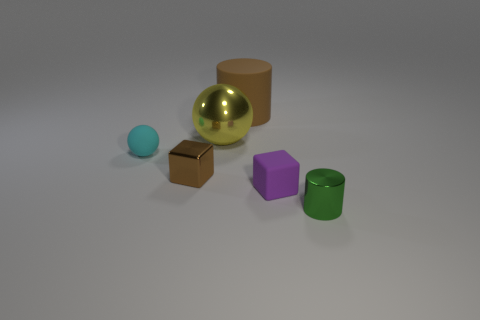The shiny object in front of the brown object that is in front of the rubber object behind the large yellow shiny thing is what shape?
Your answer should be compact. Cylinder. There is a tiny cylinder; what number of cylinders are to the left of it?
Keep it short and to the point. 1. Is the material of the cube to the left of the metallic sphere the same as the cyan ball?
Provide a short and direct response. No. How many other things are there of the same shape as the small purple object?
Your response must be concise. 1. There is a object on the left side of the small metal object that is to the left of the small shiny cylinder; how many small purple matte objects are on the right side of it?
Ensure brevity in your answer.  1. There is a cylinder that is left of the small purple matte block; what is its color?
Make the answer very short. Brown. There is a cylinder that is on the left side of the purple cube; is it the same color as the small shiny cube?
Ensure brevity in your answer.  Yes. There is a cyan object that is the same shape as the yellow shiny object; what size is it?
Ensure brevity in your answer.  Small. What is the material of the object on the right side of the small cube on the right side of the small metal object that is on the left side of the large brown cylinder?
Keep it short and to the point. Metal. Are there more large yellow metallic things that are in front of the big brown rubber cylinder than big metal spheres that are in front of the green cylinder?
Ensure brevity in your answer.  Yes. 